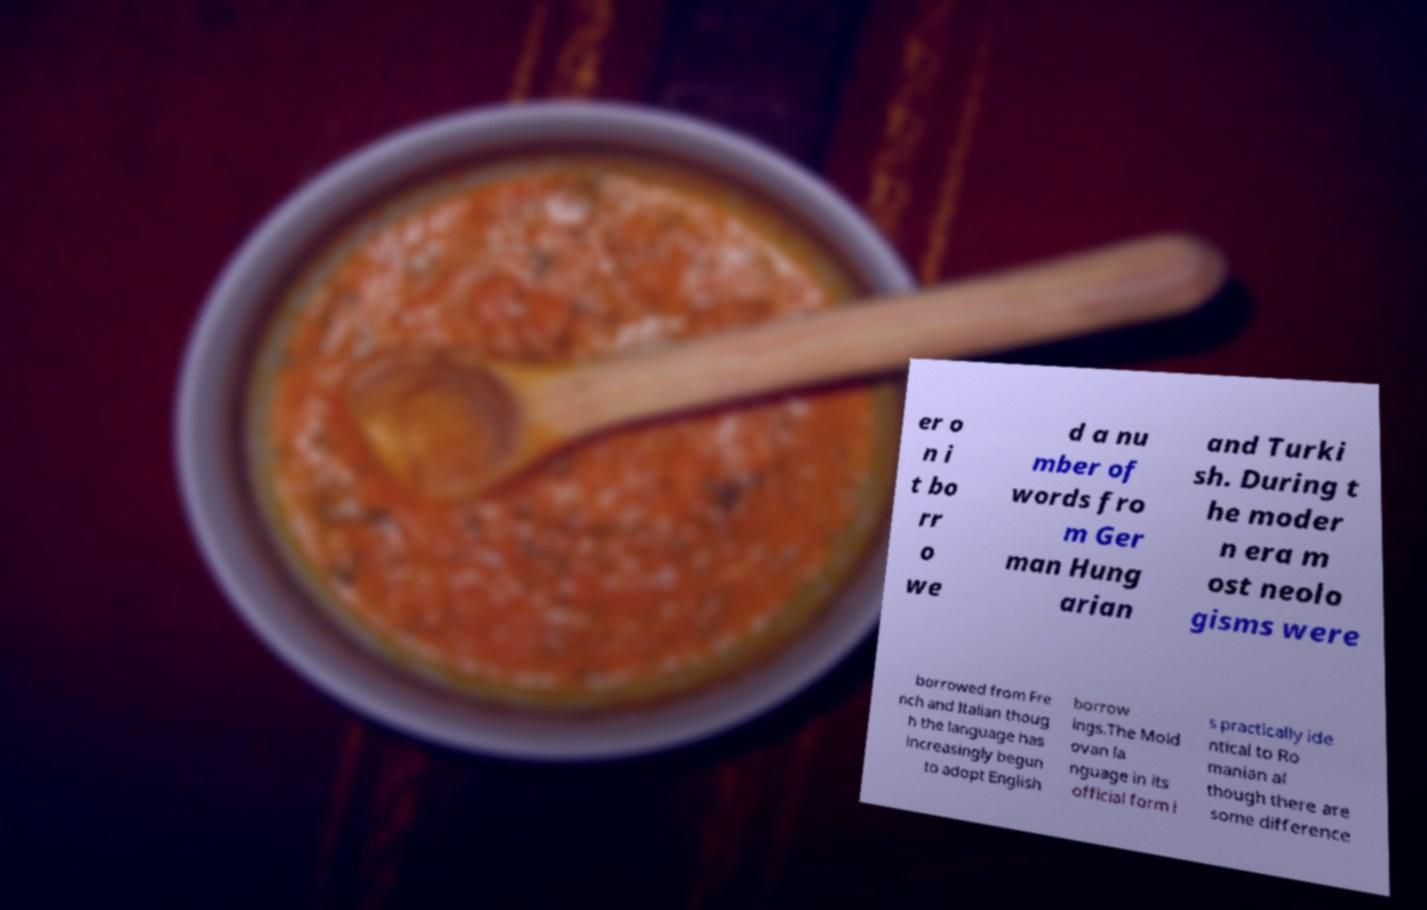For documentation purposes, I need the text within this image transcribed. Could you provide that? er o n i t bo rr o we d a nu mber of words fro m Ger man Hung arian and Turki sh. During t he moder n era m ost neolo gisms were borrowed from Fre nch and Italian thoug h the language has increasingly begun to adopt English borrow ings.The Mold ovan la nguage in its official form i s practically ide ntical to Ro manian al though there are some difference 